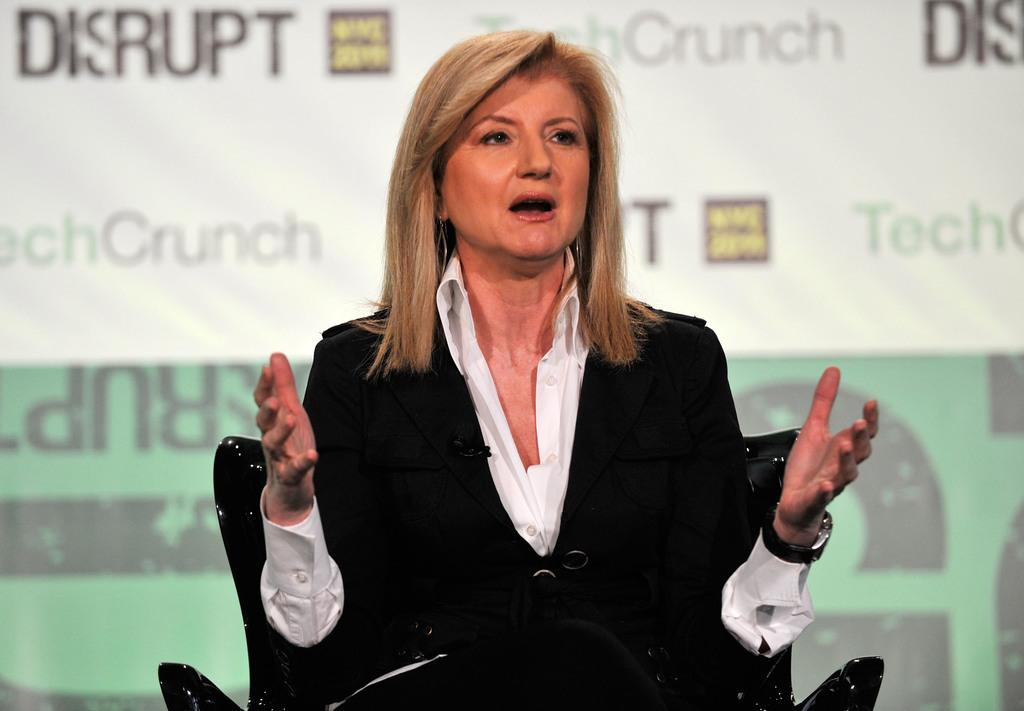Who is present in the image? There is a woman in the image. What is the woman doing in the image? The woman is sitting on a chair and talking. What can be seen in the background of the image? There is a banner in the background of the image. What color is the crayon the woman is using to draw on the banner in the image? There is no crayon or drawing activity present in the image. Why is the woman crying in the image? The woman is not crying in the image; she is talking. 